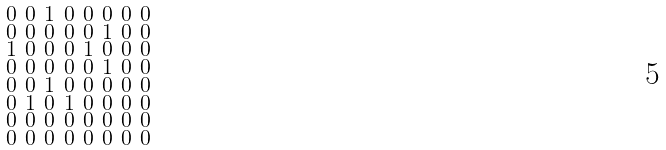Convert formula to latex. <formula><loc_0><loc_0><loc_500><loc_500>\begin{smallmatrix} 0 & 0 & 1 & 0 & 0 & 0 & 0 & 0 \\ 0 & 0 & 0 & 0 & 0 & 1 & 0 & 0 \\ 1 & 0 & 0 & 0 & 1 & 0 & 0 & 0 \\ 0 & 0 & 0 & 0 & 0 & 1 & 0 & 0 \\ 0 & 0 & 1 & 0 & 0 & 0 & 0 & 0 \\ 0 & 1 & 0 & 1 & 0 & 0 & 0 & 0 \\ 0 & 0 & 0 & 0 & 0 & 0 & 0 & 0 \\ 0 & 0 & 0 & 0 & 0 & 0 & 0 & 0 \end{smallmatrix}</formula> 